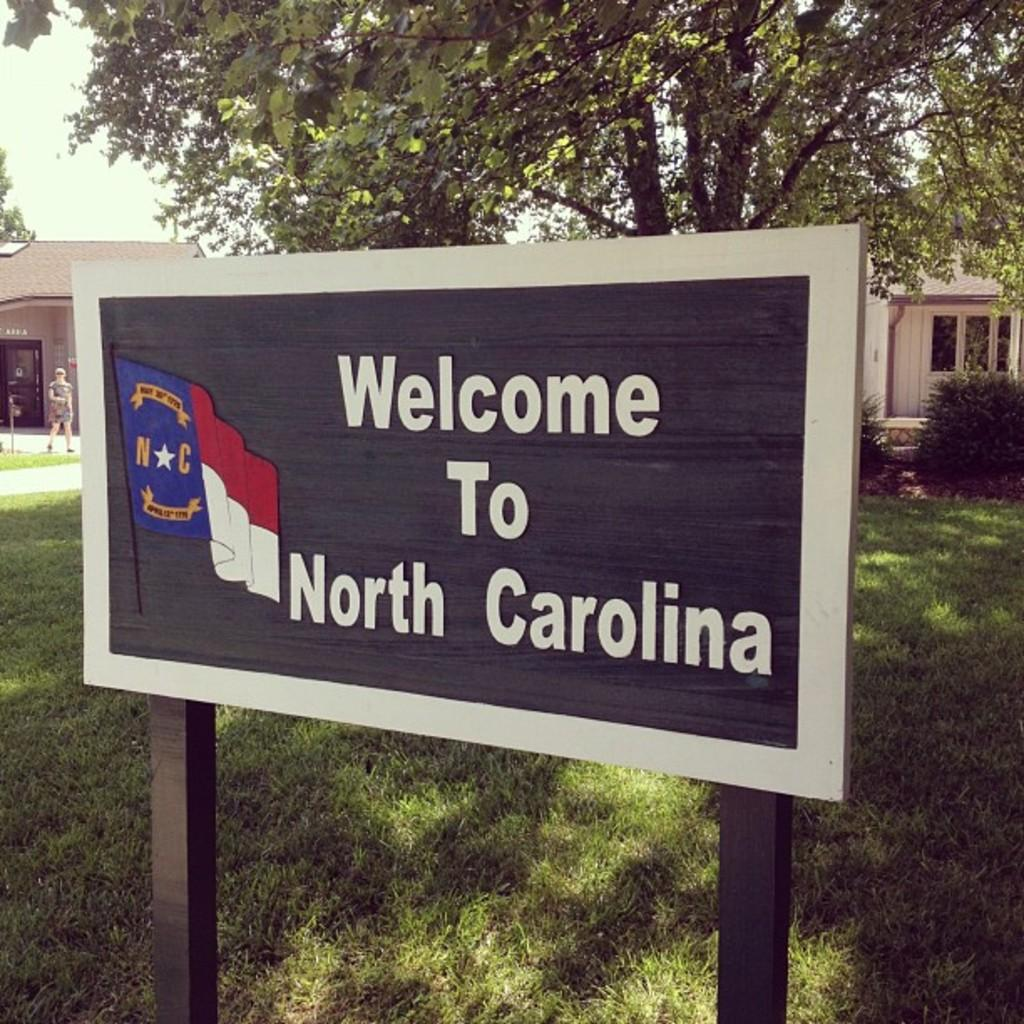What is located at the bottom of the image? There is a board at the bottom of the image. What can be seen in the background of the image? There are bushes and trees in the background of the image. What type of structures are visible in the image? There are buildings visible in the image. What is the person on the left side of the image doing? The person is walking on the left side of the image. What is visible at the top of the image? The sky is visible at the top of the image. Can you hear the owl hooting in the image? There is no owl present in the image, so it is not possible to hear it hooting. What type of army is marching through the buildings in the image? There is no army present in the image; it only shows a person walking and various structures. 